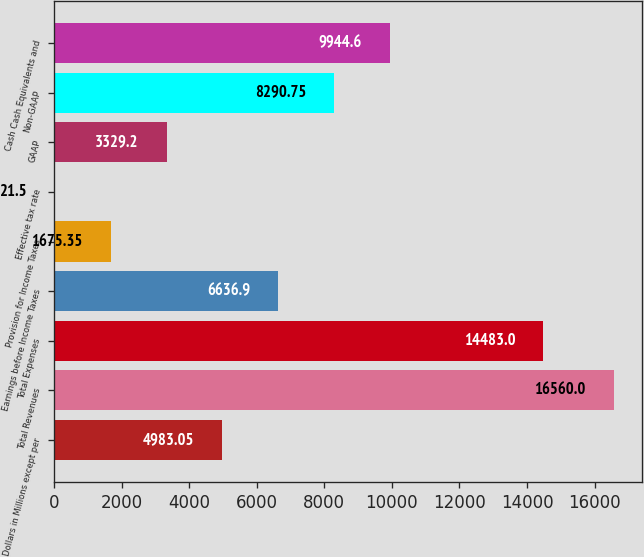<chart> <loc_0><loc_0><loc_500><loc_500><bar_chart><fcel>Dollars in Millions except per<fcel>Total Revenues<fcel>Total Expenses<fcel>Earnings before Income Taxes<fcel>Provision for Income Taxes<fcel>Effective tax rate<fcel>GAAP<fcel>Non-GAAP<fcel>Cash Cash Equivalents and<nl><fcel>4983.05<fcel>16560<fcel>14483<fcel>6636.9<fcel>1675.35<fcel>21.5<fcel>3329.2<fcel>8290.75<fcel>9944.6<nl></chart> 